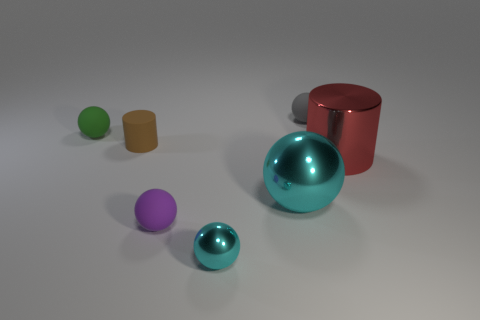What number of matte balls are the same color as the rubber cylinder?
Your answer should be very brief. 0. The small cylinder that is made of the same material as the small purple object is what color?
Your response must be concise. Brown. Are there any matte spheres that have the same size as the brown matte cylinder?
Make the answer very short. Yes. Is the number of tiny matte spheres right of the small metal thing greater than the number of things that are on the right side of the tiny brown matte cylinder?
Provide a short and direct response. No. Does the object that is behind the green matte thing have the same material as the tiny sphere left of the small purple matte thing?
Keep it short and to the point. Yes. The cyan thing that is the same size as the gray object is what shape?
Keep it short and to the point. Sphere. Is there a small green object that has the same shape as the small brown matte object?
Your answer should be very brief. No. There is a large metallic thing that is left of the large red metallic cylinder; does it have the same color as the matte object that is in front of the large shiny ball?
Make the answer very short. No. There is a brown cylinder; are there any tiny green rubber balls right of it?
Give a very brief answer. No. What is the material of the sphere that is both right of the small purple ball and behind the small brown cylinder?
Your answer should be very brief. Rubber. 